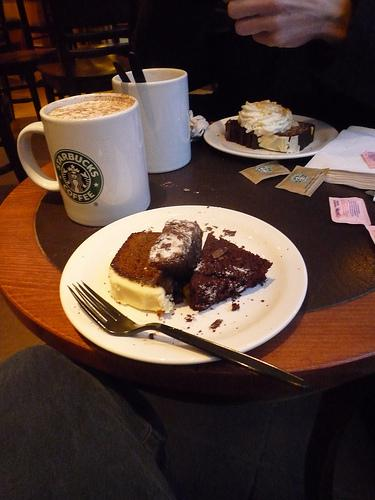Describe the diverse contents that are placed on the table. The table contains a Starbucks cup filled with hot chocolate, a plate with a piece of cake and whipped cream, sugar packets, a silver fork, and a crumpled napkin. What are the main food items shown in the image? The main food items are hot chocolate, a piece of cake with whipped cream, and sugar packets. Provide a summary of the objects seen in the image. The image features a cup of hot chocolate, cake with whipped cream, sugar packets in pink and brown, a silver fork, and a napkin on a table. Focus on the table and describe what you see displayed on it. On the table, there's a round white plate with a piece of cake topped with whipped cream, a silver fork, a Starbucks coffee mug, sugar packets, and a crumpled napkin. Point out the main components of the image related to a possible breakfast or snack. A cup of hot chocolate, a piece of cake with whipped cream, sugar packets, a silver fork, and a crumpled napkin are seen on the table. List the significant elements in the scene and the colors. A white Starbucks cup with green logo, piece of chocolate cake with whipped cream, pink and brown sugar packets, a silver fork, and a white crumpled napkin. Narrate the overall view of the items present in the image. The image displays a table with an assortment of items such as a Starbucks coffee mug, a piece of cake with whipped cream on a plate, pink and brown sugar packets, a silver fork, and a crumpled napkin. Identify and describe the primary elements associated with food in the image. The image showcases a round white plate with a piece of cake topped with whipped cream, a silver fork, a Starbucks coffee mug, packets of sugar in pink and brown, and a white crumpled napkin. Mention the primary elements present in the image. A hot chocolate cup, a piece of cake with whipped cream, sugar packets, a silver fork, and a crumpled napkin. Write a brief description of the image highlighting the key objects. The image captures a table with various items like a Starbucks coffee mug, a plate with cake and whipped cream, sugar packets, a silver fork, and a napkin. 